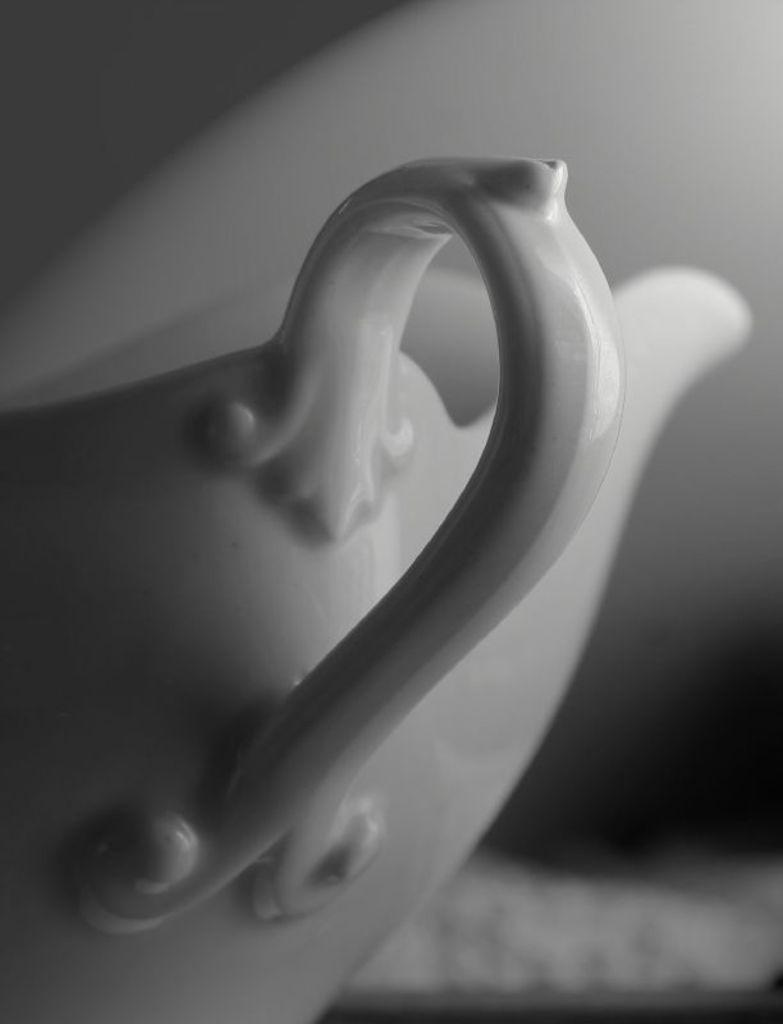What object is present in the image? There is a cup in the image. Can you describe the background of the image? The background of the image is blurry. What type of rose can be seen in the image? There is no rose present in the image; it only features a cup and a blurry background. 